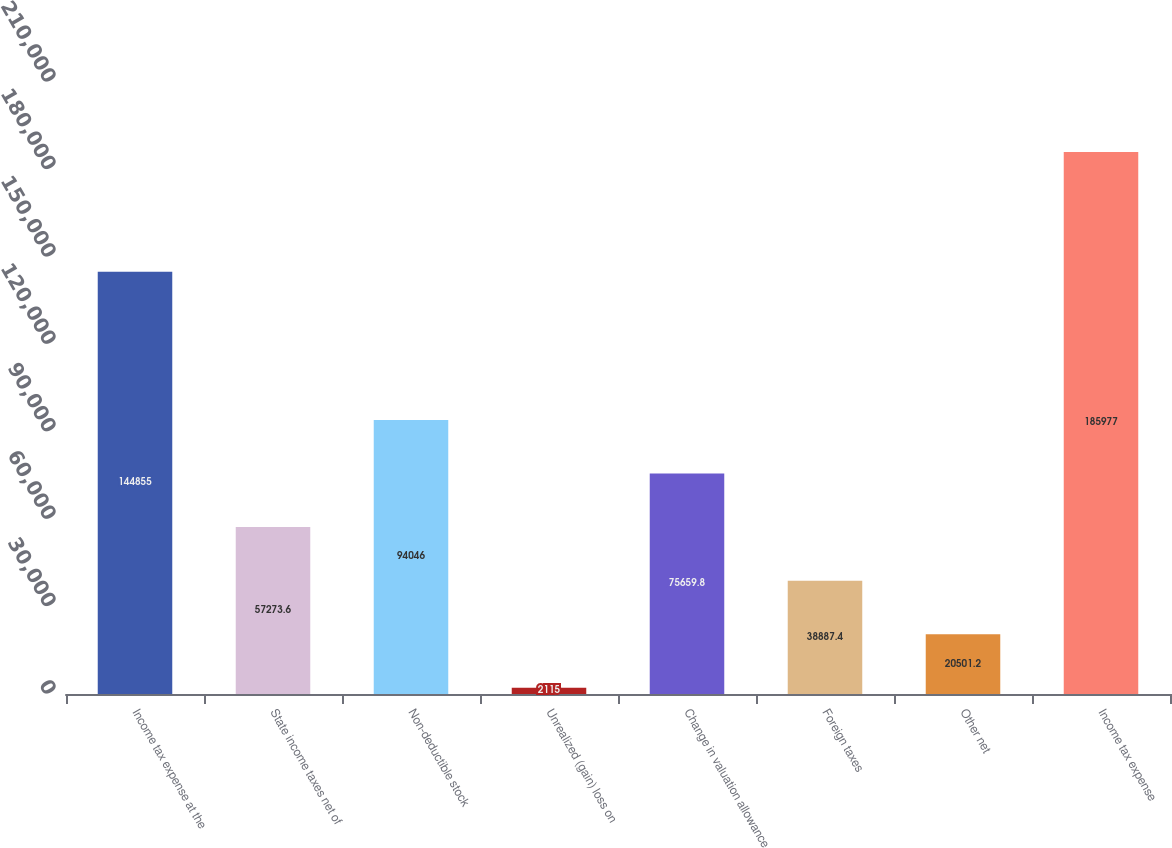<chart> <loc_0><loc_0><loc_500><loc_500><bar_chart><fcel>Income tax expense at the<fcel>State income taxes net of<fcel>Non-deductible stock<fcel>Unrealized (gain) loss on<fcel>Change in valuation allowance<fcel>Foreign taxes<fcel>Other net<fcel>Income tax expense<nl><fcel>144855<fcel>57273.6<fcel>94046<fcel>2115<fcel>75659.8<fcel>38887.4<fcel>20501.2<fcel>185977<nl></chart> 